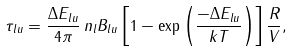<formula> <loc_0><loc_0><loc_500><loc_500>\tau _ { l u } = \frac { \Delta E _ { l u } } { 4 \pi } \, n _ { l } B _ { l u } \left [ 1 - \exp \left ( \frac { - \Delta E _ { l u } } { k T } \right ) \right ] \frac { R } { V } ,</formula> 